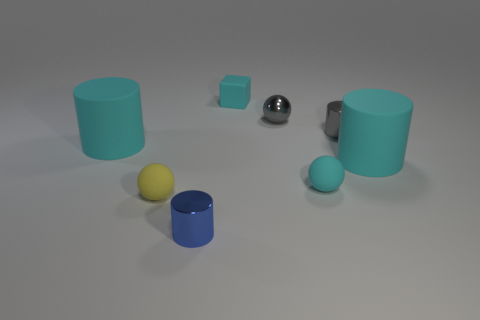What shape is the blue metallic thing that is the same size as the cube?
Your answer should be very brief. Cylinder. Is there a gray thing in front of the tiny cyan object that is in front of the tiny rubber block?
Make the answer very short. No. What color is the other shiny object that is the same shape as the yellow object?
Make the answer very short. Gray. Is the color of the small shiny cylinder that is behind the tiny yellow ball the same as the metallic ball?
Provide a short and direct response. Yes. What number of objects are either small gray metallic objects left of the small gray cylinder or small gray metallic things?
Your response must be concise. 2. What is the small cylinder in front of the small matte thing that is in front of the small cyan matte object in front of the gray ball made of?
Offer a terse response. Metal. Are there more rubber objects behind the yellow object than small gray balls that are on the right side of the small gray shiny cylinder?
Keep it short and to the point. Yes. How many cylinders are tiny cyan objects or tiny gray objects?
Keep it short and to the point. 1. There is a tiny matte object that is behind the big cyan object left of the tiny gray metallic cylinder; what number of small blue metal cylinders are in front of it?
Your answer should be compact. 1. What is the material of the tiny ball that is the same color as the tiny block?
Offer a very short reply. Rubber. 